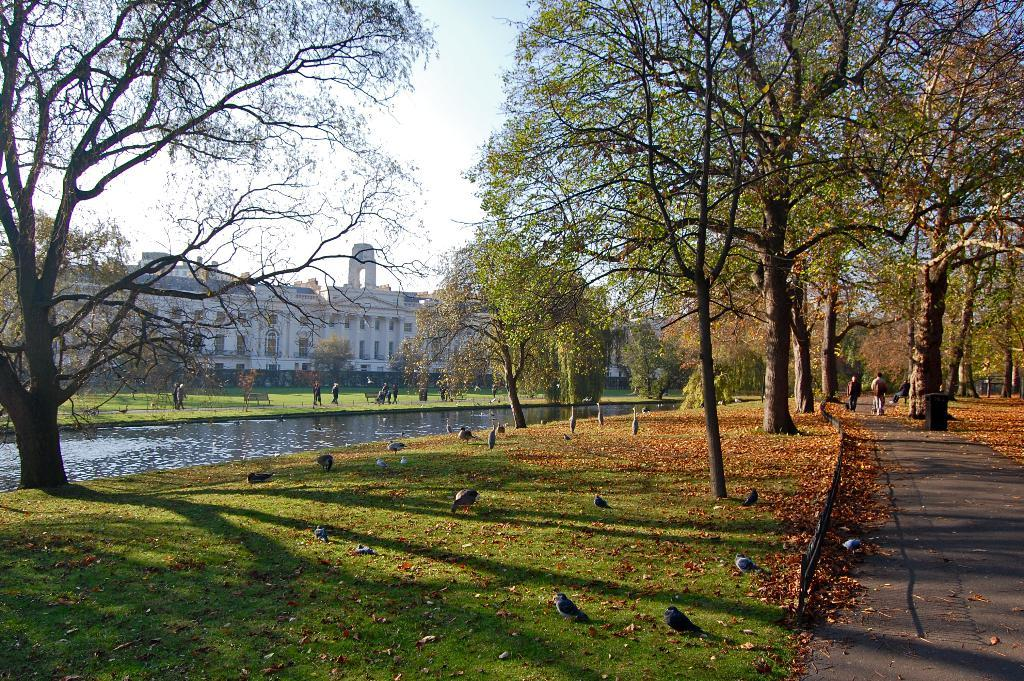What animals can be seen at the bottom of the image? There are birds at the bottom of the image. What body of water is present on the left side of the image? There is a canal on the left side of the image. What type of vegetation is near the canal? There are trees near the canal. What structure can be seen in the background of the image? There is a building in the background of the image. What is visible in the sky in the image? The sky is visible in the background of the image. What are the people in the image doing? People are walking in the image. What type of wren can be seen flying over the canal in the image? There is no wren present in the image; only birds are mentioned. What behavior do the birds exhibit in the image? The provided facts do not mention any specific behavior of the birds in the image. 